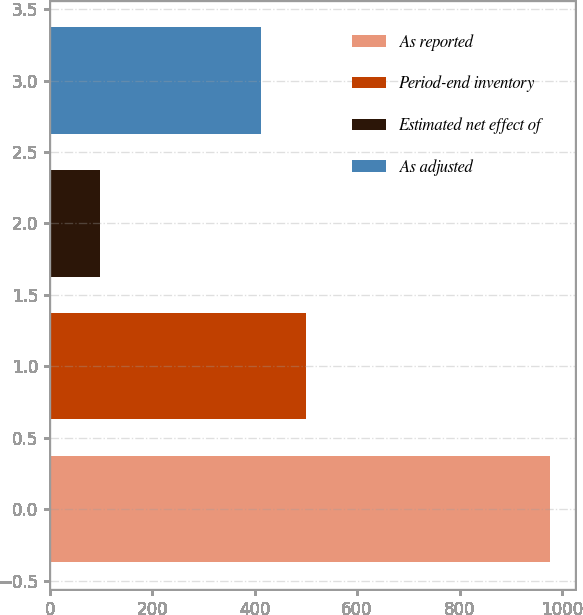Convert chart. <chart><loc_0><loc_0><loc_500><loc_500><bar_chart><fcel>As reported<fcel>Period-end inventory<fcel>Estimated net effect of<fcel>As adjusted<nl><fcel>976.5<fcel>499.67<fcel>98.8<fcel>411.9<nl></chart> 